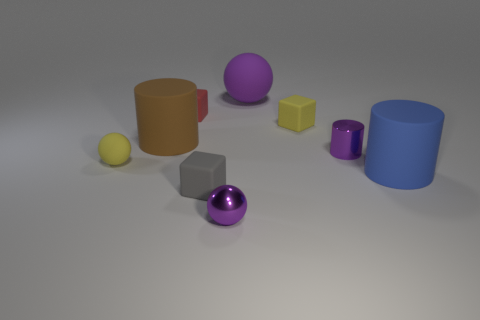There is a cylinder that is the same color as the big sphere; what is it made of?
Keep it short and to the point. Metal. Is the number of cylinders on the left side of the small purple cylinder the same as the number of brown matte objects that are behind the blue matte object?
Provide a succinct answer. Yes. Are there any other things that have the same size as the gray matte cube?
Your answer should be very brief. Yes. What material is the tiny red object that is the same shape as the tiny gray object?
Provide a short and direct response. Rubber. There is a sphere that is to the left of the cylinder that is to the left of the tiny purple sphere; is there a red cube right of it?
Offer a terse response. Yes. Is the shape of the purple shiny object in front of the purple metal cylinder the same as the purple object behind the red cube?
Make the answer very short. Yes. Is the number of things to the left of the small purple sphere greater than the number of large balls?
Make the answer very short. Yes. How many objects are tiny rubber spheres or green rubber cylinders?
Your answer should be very brief. 1. The tiny metallic cylinder has what color?
Your answer should be very brief. Purple. What number of other things are the same color as the metallic cylinder?
Offer a very short reply. 2. 